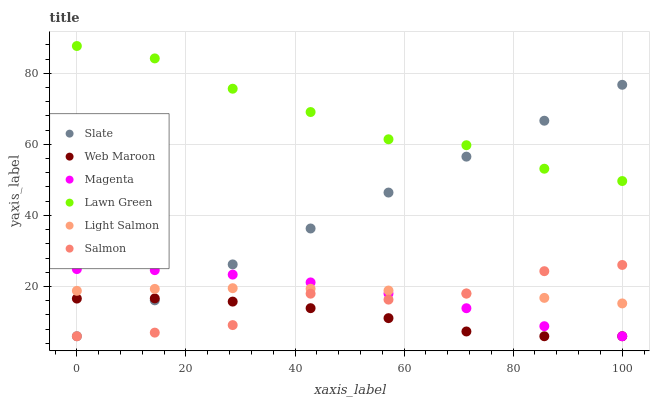Does Web Maroon have the minimum area under the curve?
Answer yes or no. Yes. Does Lawn Green have the maximum area under the curve?
Answer yes or no. Yes. Does Light Salmon have the minimum area under the curve?
Answer yes or no. No. Does Light Salmon have the maximum area under the curve?
Answer yes or no. No. Is Slate the smoothest?
Answer yes or no. Yes. Is Salmon the roughest?
Answer yes or no. Yes. Is Light Salmon the smoothest?
Answer yes or no. No. Is Light Salmon the roughest?
Answer yes or no. No. Does Web Maroon have the lowest value?
Answer yes or no. Yes. Does Light Salmon have the lowest value?
Answer yes or no. No. Does Lawn Green have the highest value?
Answer yes or no. Yes. Does Light Salmon have the highest value?
Answer yes or no. No. Is Web Maroon less than Light Salmon?
Answer yes or no. Yes. Is Lawn Green greater than Salmon?
Answer yes or no. Yes. Does Slate intersect Light Salmon?
Answer yes or no. Yes. Is Slate less than Light Salmon?
Answer yes or no. No. Is Slate greater than Light Salmon?
Answer yes or no. No. Does Web Maroon intersect Light Salmon?
Answer yes or no. No. 